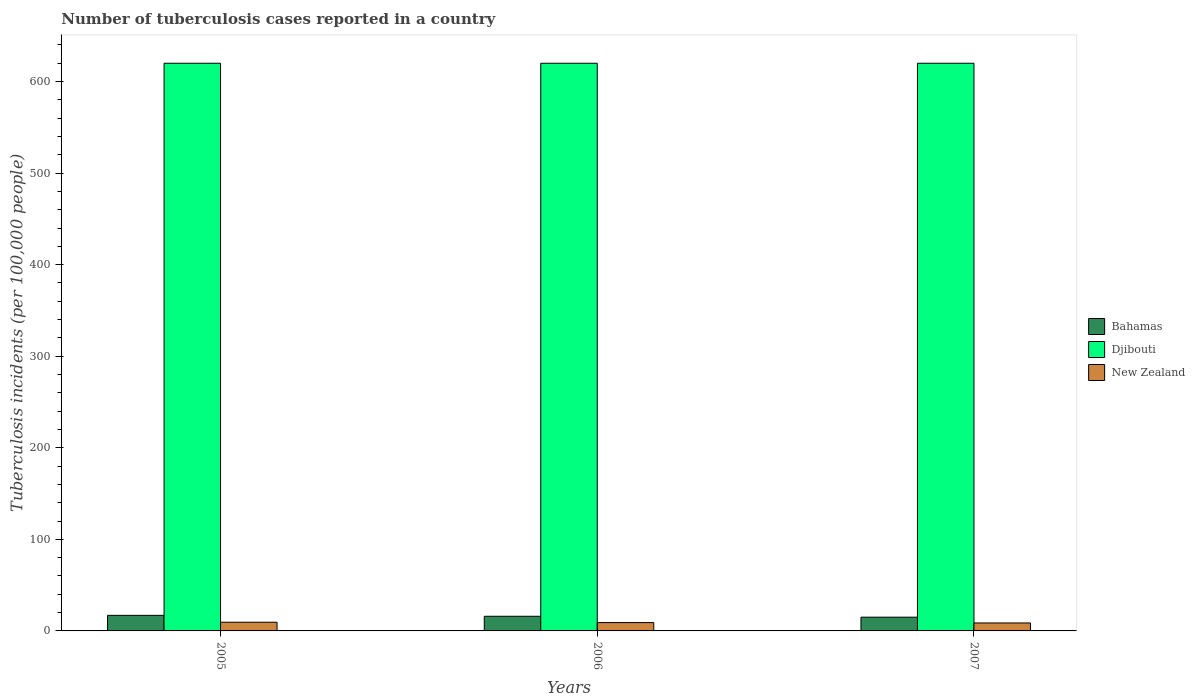How many groups of bars are there?
Offer a terse response. 3. Are the number of bars per tick equal to the number of legend labels?
Make the answer very short. Yes. Are the number of bars on each tick of the X-axis equal?
Offer a very short reply. Yes. How many bars are there on the 1st tick from the left?
Provide a short and direct response. 3. What is the number of tuberculosis cases reported in in Djibouti in 2006?
Offer a very short reply. 620. Across all years, what is the maximum number of tuberculosis cases reported in in Bahamas?
Your answer should be very brief. 17. Across all years, what is the minimum number of tuberculosis cases reported in in Bahamas?
Ensure brevity in your answer.  15. In which year was the number of tuberculosis cases reported in in Djibouti maximum?
Ensure brevity in your answer.  2005. In which year was the number of tuberculosis cases reported in in Bahamas minimum?
Make the answer very short. 2007. What is the total number of tuberculosis cases reported in in Bahamas in the graph?
Give a very brief answer. 48. What is the difference between the number of tuberculosis cases reported in in Bahamas in 2005 and that in 2006?
Offer a very short reply. 1. What is the difference between the number of tuberculosis cases reported in in Bahamas in 2005 and the number of tuberculosis cases reported in in Djibouti in 2006?
Your response must be concise. -603. What is the average number of tuberculosis cases reported in in New Zealand per year?
Offer a very short reply. 9.1. In the year 2005, what is the difference between the number of tuberculosis cases reported in in Djibouti and number of tuberculosis cases reported in in Bahamas?
Your answer should be very brief. 603. In how many years, is the number of tuberculosis cases reported in in Djibouti greater than 440?
Your response must be concise. 3. What is the ratio of the number of tuberculosis cases reported in in New Zealand in 2005 to that in 2007?
Your response must be concise. 1.09. Is the difference between the number of tuberculosis cases reported in in Djibouti in 2005 and 2007 greater than the difference between the number of tuberculosis cases reported in in Bahamas in 2005 and 2007?
Your response must be concise. No. What is the difference between the highest and the second highest number of tuberculosis cases reported in in Bahamas?
Your answer should be compact. 1. What is the difference between the highest and the lowest number of tuberculosis cases reported in in Djibouti?
Keep it short and to the point. 0. In how many years, is the number of tuberculosis cases reported in in New Zealand greater than the average number of tuberculosis cases reported in in New Zealand taken over all years?
Your answer should be very brief. 1. Is the sum of the number of tuberculosis cases reported in in Bahamas in 2005 and 2007 greater than the maximum number of tuberculosis cases reported in in Djibouti across all years?
Make the answer very short. No. What does the 3rd bar from the left in 2005 represents?
Your response must be concise. New Zealand. What does the 1st bar from the right in 2006 represents?
Offer a very short reply. New Zealand. Are all the bars in the graph horizontal?
Ensure brevity in your answer.  No. How many years are there in the graph?
Offer a terse response. 3. What is the difference between two consecutive major ticks on the Y-axis?
Give a very brief answer. 100. Does the graph contain any zero values?
Provide a short and direct response. No. Where does the legend appear in the graph?
Make the answer very short. Center right. How are the legend labels stacked?
Give a very brief answer. Vertical. What is the title of the graph?
Your response must be concise. Number of tuberculosis cases reported in a country. Does "Qatar" appear as one of the legend labels in the graph?
Provide a succinct answer. No. What is the label or title of the Y-axis?
Give a very brief answer. Tuberculosis incidents (per 100,0 people). What is the Tuberculosis incidents (per 100,000 people) in Djibouti in 2005?
Make the answer very short. 620. What is the Tuberculosis incidents (per 100,000 people) of New Zealand in 2005?
Your response must be concise. 9.5. What is the Tuberculosis incidents (per 100,000 people) of Bahamas in 2006?
Keep it short and to the point. 16. What is the Tuberculosis incidents (per 100,000 people) in Djibouti in 2006?
Keep it short and to the point. 620. What is the Tuberculosis incidents (per 100,000 people) of Bahamas in 2007?
Make the answer very short. 15. What is the Tuberculosis incidents (per 100,000 people) of Djibouti in 2007?
Offer a very short reply. 620. Across all years, what is the maximum Tuberculosis incidents (per 100,000 people) in Bahamas?
Provide a short and direct response. 17. Across all years, what is the maximum Tuberculosis incidents (per 100,000 people) of Djibouti?
Ensure brevity in your answer.  620. Across all years, what is the minimum Tuberculosis incidents (per 100,000 people) of Bahamas?
Make the answer very short. 15. Across all years, what is the minimum Tuberculosis incidents (per 100,000 people) in Djibouti?
Provide a succinct answer. 620. Across all years, what is the minimum Tuberculosis incidents (per 100,000 people) of New Zealand?
Offer a very short reply. 8.7. What is the total Tuberculosis incidents (per 100,000 people) of Bahamas in the graph?
Offer a terse response. 48. What is the total Tuberculosis incidents (per 100,000 people) in Djibouti in the graph?
Make the answer very short. 1860. What is the total Tuberculosis incidents (per 100,000 people) in New Zealand in the graph?
Offer a very short reply. 27.3. What is the difference between the Tuberculosis incidents (per 100,000 people) of Djibouti in 2005 and that in 2006?
Provide a short and direct response. 0. What is the difference between the Tuberculosis incidents (per 100,000 people) of Bahamas in 2005 and that in 2007?
Your response must be concise. 2. What is the difference between the Tuberculosis incidents (per 100,000 people) in Djibouti in 2006 and that in 2007?
Offer a terse response. 0. What is the difference between the Tuberculosis incidents (per 100,000 people) in New Zealand in 2006 and that in 2007?
Offer a very short reply. 0.4. What is the difference between the Tuberculosis incidents (per 100,000 people) of Bahamas in 2005 and the Tuberculosis incidents (per 100,000 people) of Djibouti in 2006?
Your answer should be very brief. -603. What is the difference between the Tuberculosis incidents (per 100,000 people) in Djibouti in 2005 and the Tuberculosis incidents (per 100,000 people) in New Zealand in 2006?
Make the answer very short. 610.9. What is the difference between the Tuberculosis incidents (per 100,000 people) of Bahamas in 2005 and the Tuberculosis incidents (per 100,000 people) of Djibouti in 2007?
Your answer should be compact. -603. What is the difference between the Tuberculosis incidents (per 100,000 people) in Djibouti in 2005 and the Tuberculosis incidents (per 100,000 people) in New Zealand in 2007?
Give a very brief answer. 611.3. What is the difference between the Tuberculosis incidents (per 100,000 people) of Bahamas in 2006 and the Tuberculosis incidents (per 100,000 people) of Djibouti in 2007?
Keep it short and to the point. -604. What is the difference between the Tuberculosis incidents (per 100,000 people) of Bahamas in 2006 and the Tuberculosis incidents (per 100,000 people) of New Zealand in 2007?
Ensure brevity in your answer.  7.3. What is the difference between the Tuberculosis incidents (per 100,000 people) of Djibouti in 2006 and the Tuberculosis incidents (per 100,000 people) of New Zealand in 2007?
Your response must be concise. 611.3. What is the average Tuberculosis incidents (per 100,000 people) of Bahamas per year?
Provide a short and direct response. 16. What is the average Tuberculosis incidents (per 100,000 people) in Djibouti per year?
Provide a succinct answer. 620. What is the average Tuberculosis incidents (per 100,000 people) in New Zealand per year?
Your answer should be compact. 9.1. In the year 2005, what is the difference between the Tuberculosis incidents (per 100,000 people) of Bahamas and Tuberculosis incidents (per 100,000 people) of Djibouti?
Your answer should be very brief. -603. In the year 2005, what is the difference between the Tuberculosis incidents (per 100,000 people) of Djibouti and Tuberculosis incidents (per 100,000 people) of New Zealand?
Ensure brevity in your answer.  610.5. In the year 2006, what is the difference between the Tuberculosis incidents (per 100,000 people) of Bahamas and Tuberculosis incidents (per 100,000 people) of Djibouti?
Make the answer very short. -604. In the year 2006, what is the difference between the Tuberculosis incidents (per 100,000 people) of Djibouti and Tuberculosis incidents (per 100,000 people) of New Zealand?
Give a very brief answer. 610.9. In the year 2007, what is the difference between the Tuberculosis incidents (per 100,000 people) in Bahamas and Tuberculosis incidents (per 100,000 people) in Djibouti?
Your response must be concise. -605. In the year 2007, what is the difference between the Tuberculosis incidents (per 100,000 people) of Djibouti and Tuberculosis incidents (per 100,000 people) of New Zealand?
Provide a succinct answer. 611.3. What is the ratio of the Tuberculosis incidents (per 100,000 people) of Bahamas in 2005 to that in 2006?
Give a very brief answer. 1.06. What is the ratio of the Tuberculosis incidents (per 100,000 people) in New Zealand in 2005 to that in 2006?
Your response must be concise. 1.04. What is the ratio of the Tuberculosis incidents (per 100,000 people) in Bahamas in 2005 to that in 2007?
Keep it short and to the point. 1.13. What is the ratio of the Tuberculosis incidents (per 100,000 people) of New Zealand in 2005 to that in 2007?
Ensure brevity in your answer.  1.09. What is the ratio of the Tuberculosis incidents (per 100,000 people) of Bahamas in 2006 to that in 2007?
Your response must be concise. 1.07. What is the ratio of the Tuberculosis incidents (per 100,000 people) in Djibouti in 2006 to that in 2007?
Provide a succinct answer. 1. What is the ratio of the Tuberculosis incidents (per 100,000 people) in New Zealand in 2006 to that in 2007?
Your response must be concise. 1.05. What is the difference between the highest and the second highest Tuberculosis incidents (per 100,000 people) in Bahamas?
Provide a short and direct response. 1. What is the difference between the highest and the second highest Tuberculosis incidents (per 100,000 people) of New Zealand?
Give a very brief answer. 0.4. What is the difference between the highest and the lowest Tuberculosis incidents (per 100,000 people) in Bahamas?
Offer a terse response. 2. What is the difference between the highest and the lowest Tuberculosis incidents (per 100,000 people) of Djibouti?
Offer a terse response. 0. 